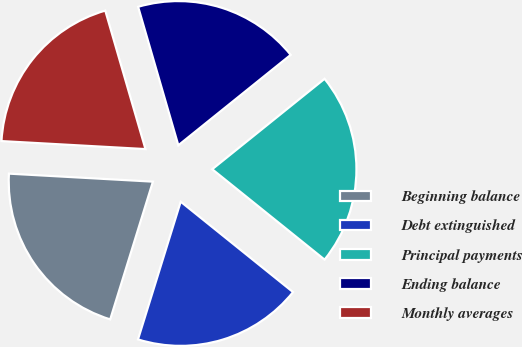Convert chart. <chart><loc_0><loc_0><loc_500><loc_500><pie_chart><fcel>Beginning balance<fcel>Debt extinguished<fcel>Principal payments<fcel>Ending balance<fcel>Monthly averages<nl><fcel>21.1%<fcel>19.0%<fcel>21.57%<fcel>18.71%<fcel>19.62%<nl></chart> 